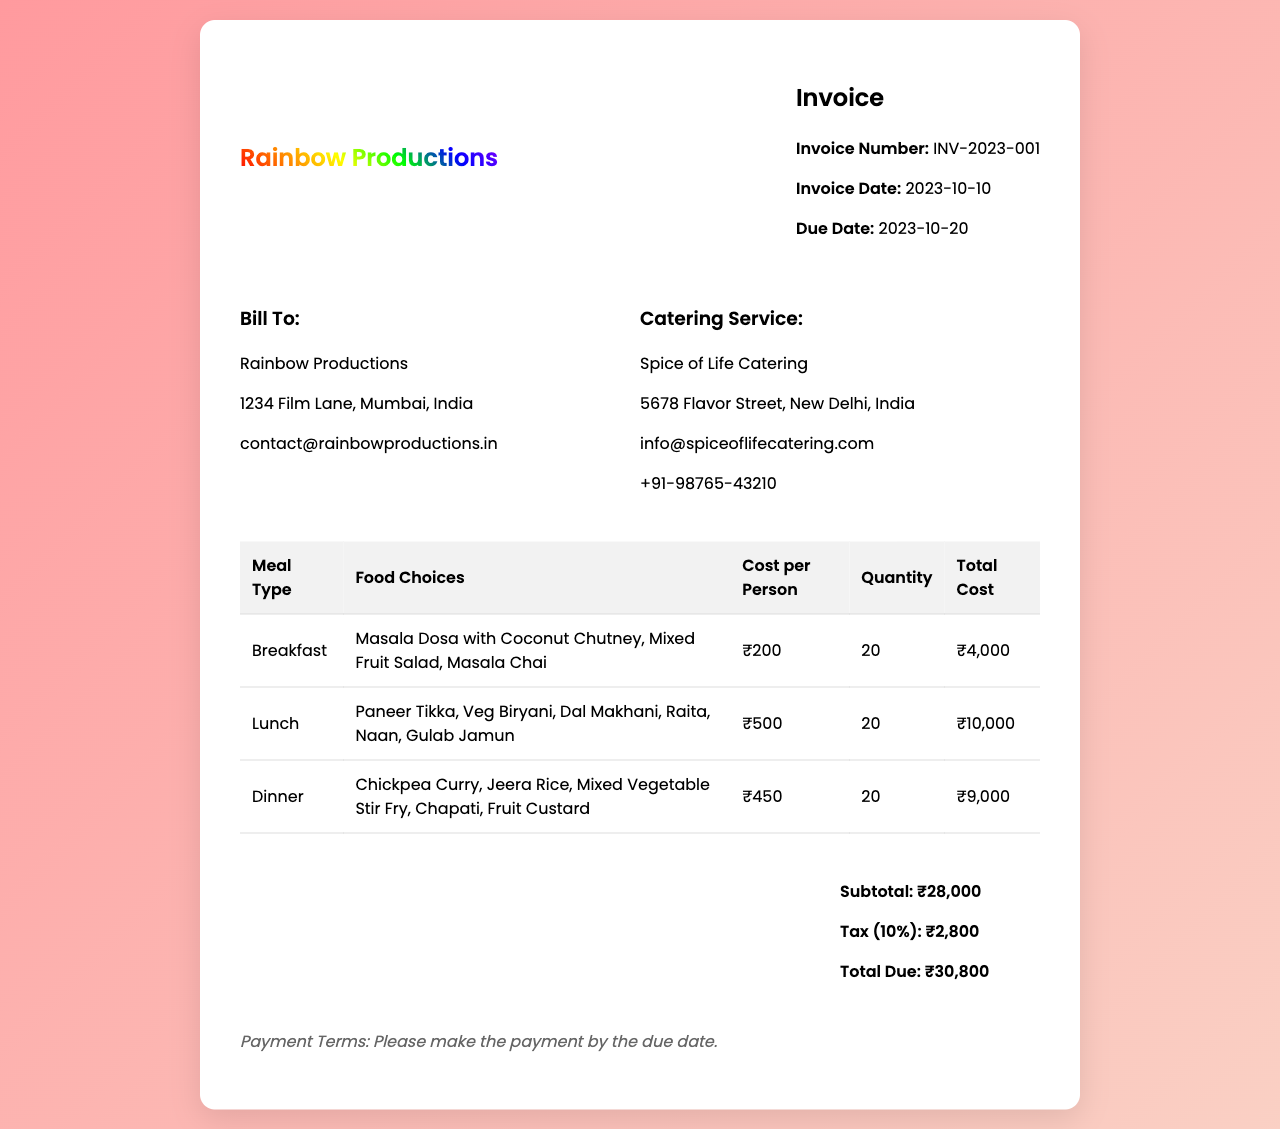What is the invoice number? The invoice number is listed in the header of the document.
Answer: INV-2023-001 What is the total due amount? The total due amount is calculated from the subtotal and tax displayed in the document.
Answer: ₹30,800 Who is the catering service provider? The catering service provider's name is found under the "Catering Service" section.
Answer: Spice of Life Catering How many meals were ordered for lunch? The quantity of meals for lunch is specified in the table under the "Quantity" column for lunch.
Answer: 20 What is the cost per person for breakfast? The cost per person for breakfast is indicated in the "Cost per Person" column of the table for breakfast.
Answer: ₹200 What is the subtotal before tax? The subtotal before tax is mentioned in the total section of the document.
Answer: ₹28,000 What is the payment term? The payment term is listed towards the bottom of the document, specifying when payment is due.
Answer: Please make the payment by the due date What types of food were served for dinner? The food choices for dinner can be found in the table under the "Food Choices" section for dinner.
Answer: Chickpea Curry, Jeera Rice, Mixed Vegetable Stir Fry, Chapati, Fruit Custard What is the tax rate applied? The tax rate is mentioned in the total section of the document.
Answer: 10% When is the due date for payment? The due date for payment is stated in the header section of the document.
Answer: 2023-10-20 